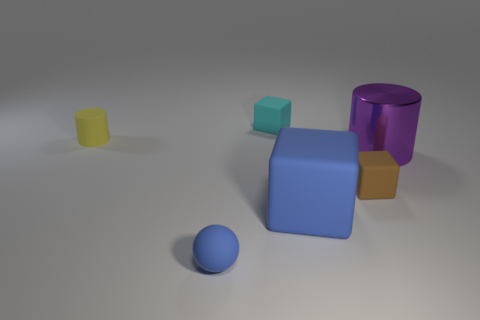Subtract all spheres. How many objects are left? 5 Add 2 brown metallic cylinders. How many objects exist? 8 Subtract all tiny brown rubber things. Subtract all tiny blue matte balls. How many objects are left? 4 Add 1 yellow cylinders. How many yellow cylinders are left? 2 Add 4 small matte cylinders. How many small matte cylinders exist? 5 Subtract 0 cyan balls. How many objects are left? 6 